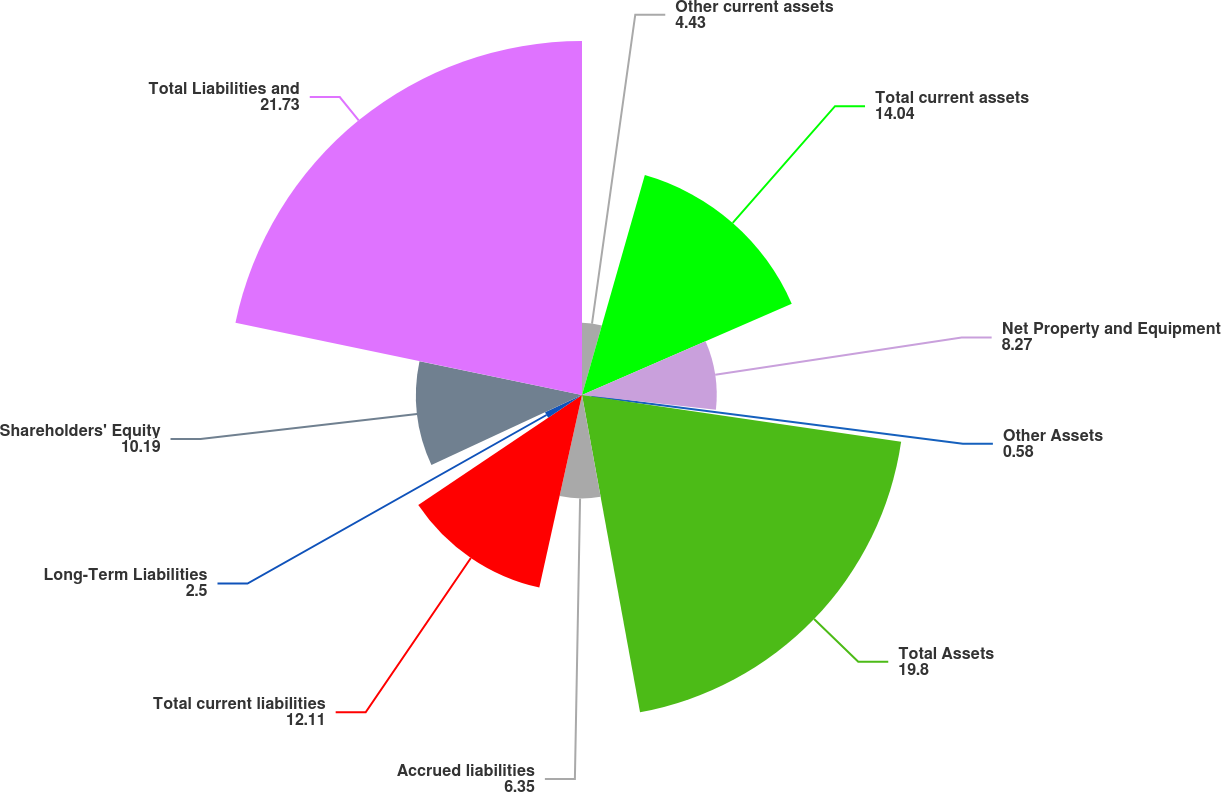<chart> <loc_0><loc_0><loc_500><loc_500><pie_chart><fcel>Other current assets<fcel>Total current assets<fcel>Net Property and Equipment<fcel>Other Assets<fcel>Total Assets<fcel>Accrued liabilities<fcel>Total current liabilities<fcel>Long-Term Liabilities<fcel>Shareholders' Equity<fcel>Total Liabilities and<nl><fcel>4.43%<fcel>14.04%<fcel>8.27%<fcel>0.58%<fcel>19.8%<fcel>6.35%<fcel>12.11%<fcel>2.5%<fcel>10.19%<fcel>21.73%<nl></chart> 